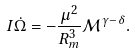Convert formula to latex. <formula><loc_0><loc_0><loc_500><loc_500>I \dot { \Omega } = - \frac { \mu ^ { 2 } } { R _ { m } ^ { 3 } } \mathcal { M } ^ { \gamma - \delta } .</formula> 